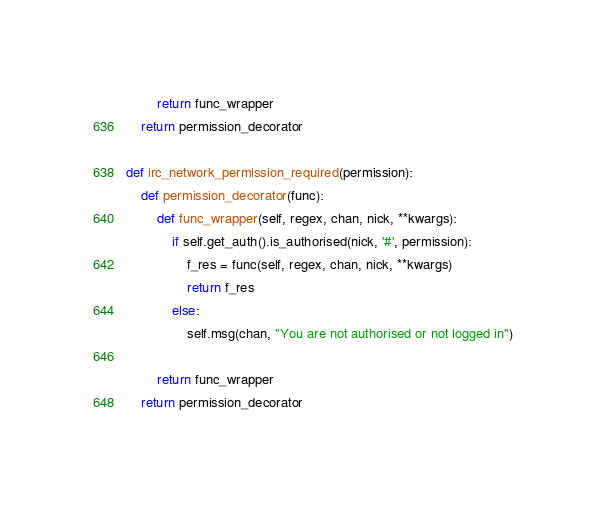<code> <loc_0><loc_0><loc_500><loc_500><_Python_>
        return func_wrapper
    return permission_decorator

def irc_network_permission_required(permission):
    def permission_decorator(func):
        def func_wrapper(self, regex, chan, nick, **kwargs):
            if self.get_auth().is_authorised(nick, '#', permission):
                f_res = func(self, regex, chan, nick, **kwargs)
                return f_res
            else:
                self.msg(chan, "You are not authorised or not logged in")

        return func_wrapper
    return permission_decorator


</code> 